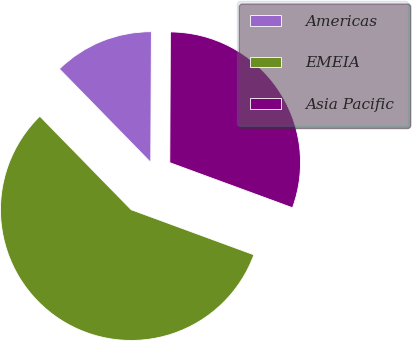Convert chart. <chart><loc_0><loc_0><loc_500><loc_500><pie_chart><fcel>Americas<fcel>EMEIA<fcel>Asia Pacific<nl><fcel>12.39%<fcel>57.08%<fcel>30.53%<nl></chart> 